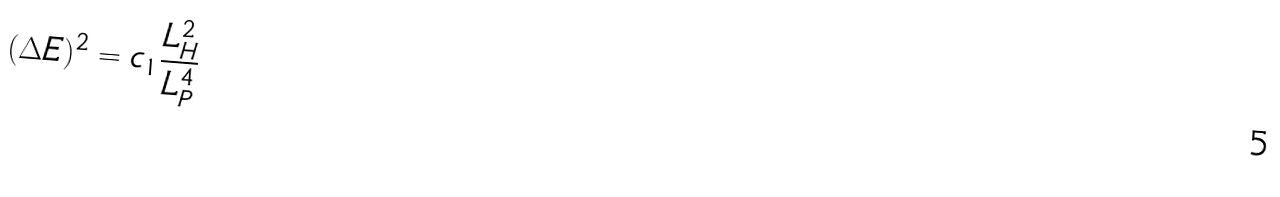Convert formula to latex. <formula><loc_0><loc_0><loc_500><loc_500>( \Delta E ) ^ { 2 } = c _ { 1 } \frac { L _ { H } ^ { 2 } } { L _ { P } ^ { 4 } }</formula> 